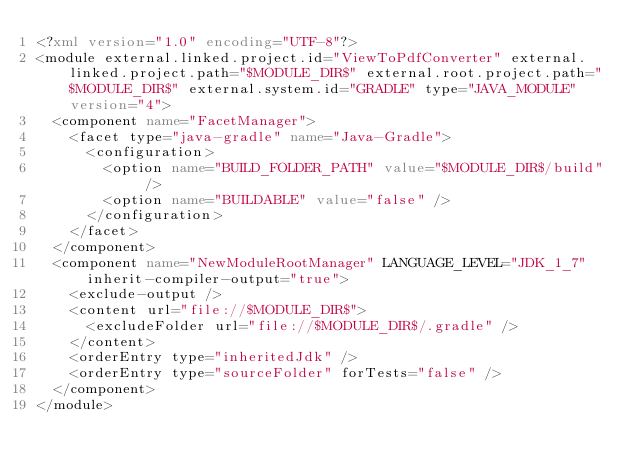<code> <loc_0><loc_0><loc_500><loc_500><_XML_><?xml version="1.0" encoding="UTF-8"?>
<module external.linked.project.id="ViewToPdfConverter" external.linked.project.path="$MODULE_DIR$" external.root.project.path="$MODULE_DIR$" external.system.id="GRADLE" type="JAVA_MODULE" version="4">
  <component name="FacetManager">
    <facet type="java-gradle" name="Java-Gradle">
      <configuration>
        <option name="BUILD_FOLDER_PATH" value="$MODULE_DIR$/build" />
        <option name="BUILDABLE" value="false" />
      </configuration>
    </facet>
  </component>
  <component name="NewModuleRootManager" LANGUAGE_LEVEL="JDK_1_7" inherit-compiler-output="true">
    <exclude-output />
    <content url="file://$MODULE_DIR$">
      <excludeFolder url="file://$MODULE_DIR$/.gradle" />
    </content>
    <orderEntry type="inheritedJdk" />
    <orderEntry type="sourceFolder" forTests="false" />
  </component>
</module></code> 